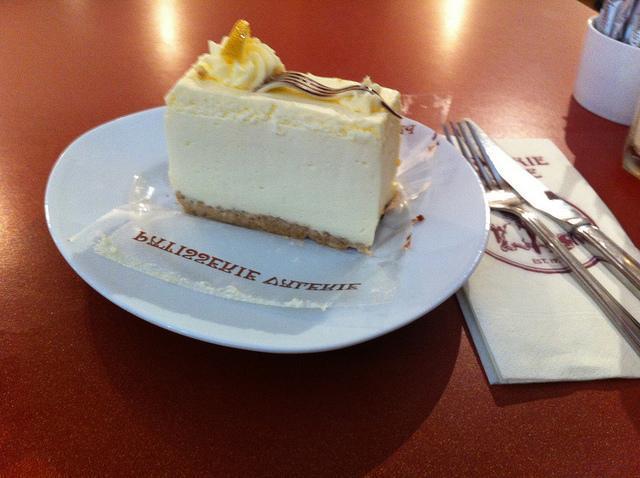How many knives are there?
Give a very brief answer. 1. 